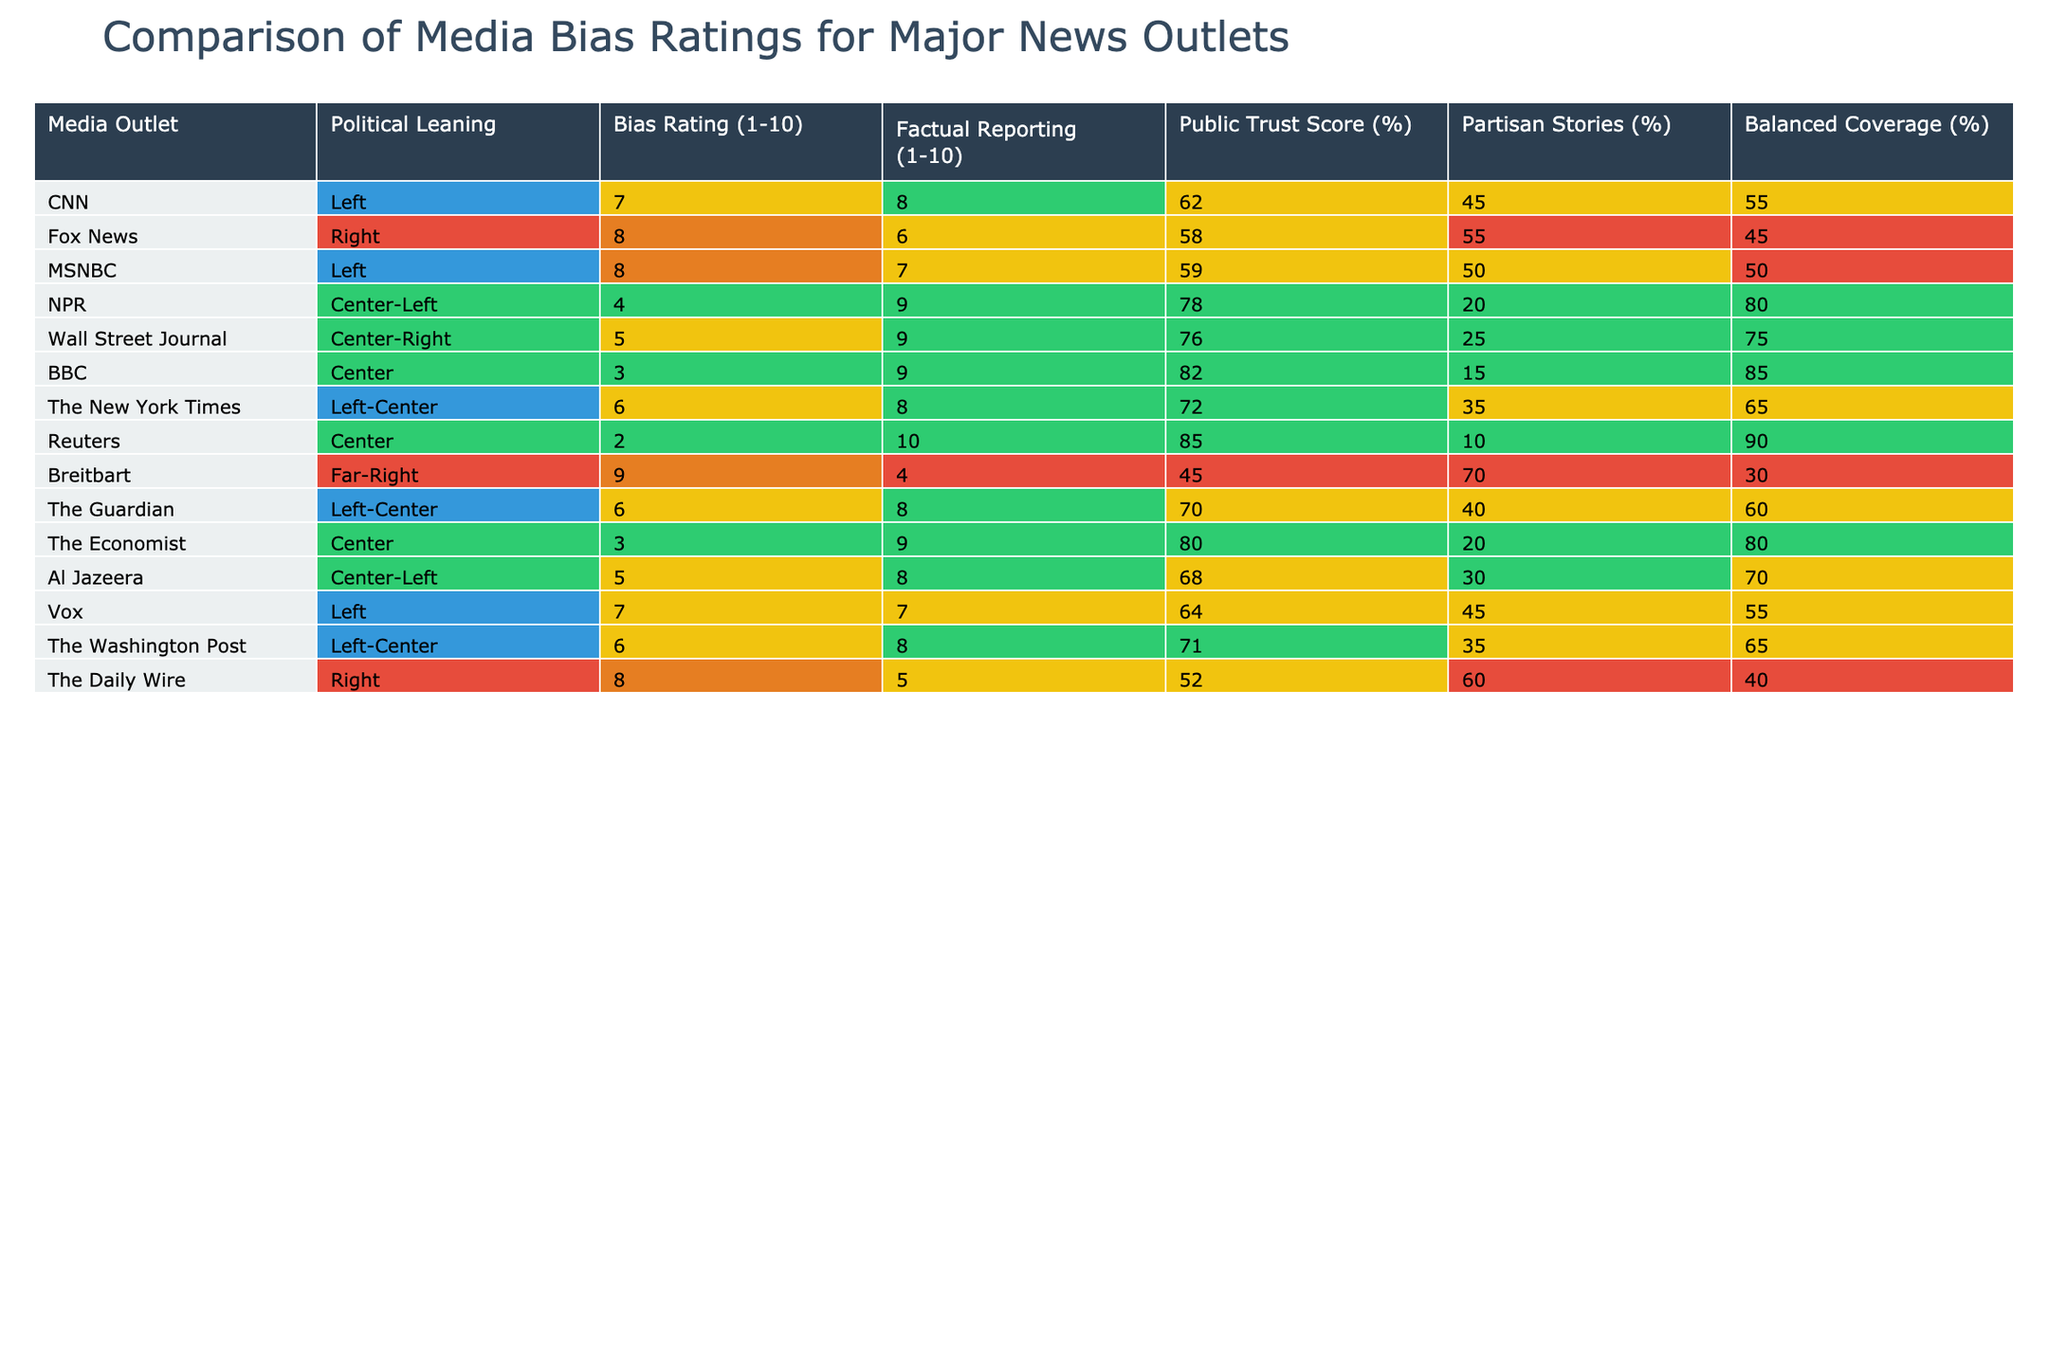What is the bias rating of NPR? The table shows that NPR has a bias rating of 4.
Answer: 4 Which media outlet has the highest public trust score? By scanning the table, I can see that Reuters has the highest public trust score at 85%.
Answer: 85% Is the bias rating for Fox News higher than that for The Guardian? Fox News has a bias rating of 8 and The Guardian has a bias rating of 6, so yes, Fox News's rating is higher.
Answer: Yes What is the average factual reporting score for the Left-leaning media outlets? The Left-leaning outlets are CNN (8), MSNBC (7), NPR (9), The New York Times (8), Vox (7), and The Guardian (8). The average is calculated as (8+7+9+8+7+8)/6 = 7.67.
Answer: 7.67 Does any media outlet with a Right-leaning bias have a balanced coverage percentage higher than 50%? The Daily Wire (40%) and Fox News (45%) do not have balanced coverage percentages higher than 50%. So the answer is no.
Answer: No Which media outlet has the lowest bias rating, and what is that rating? The table indicates that Reuters has the lowest bias rating of 2.
Answer: 2 Is it true that MSNBC and CNN have the same percentage of partisan stories? MSNBC has 50% partisan stories, while CNN has 45%, indicating that they do not have the same percentage.
Answer: No What is the difference in public trust scores between BBC and The Daily Wire? BBC has a public trust score of 82% and The Daily Wire has 52%. The difference is 82 - 52 = 30%.
Answer: 30% Which media outlet has the highest bias rating, and what is that rating compared to the bias rating of Breitbart? Breitbart has a bias rating of 9, which is the highest, compared to CNN which has a rating of 7, making Breitbart's rating higher.
Answer: Breitbart has the highest rating of 9 